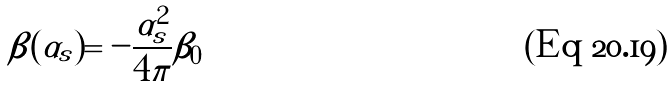Convert formula to latex. <formula><loc_0><loc_0><loc_500><loc_500>\beta ( \alpha _ { s } ) = - \frac { \alpha _ { s } ^ { 2 } } { 4 \pi } \beta _ { 0 }</formula> 